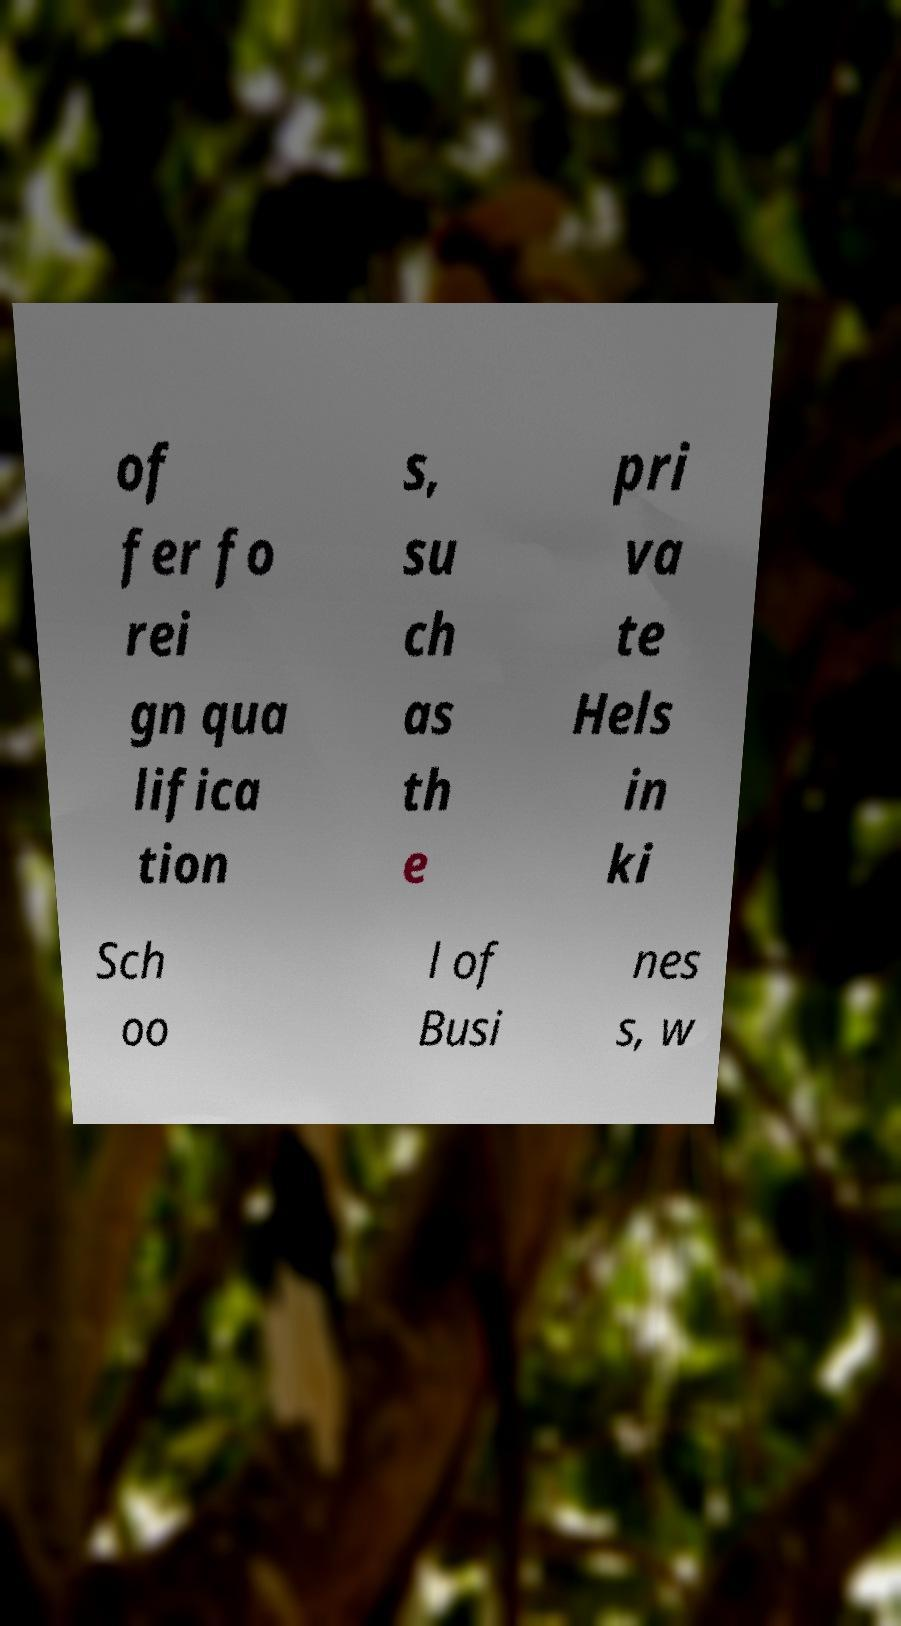What messages or text are displayed in this image? I need them in a readable, typed format. of fer fo rei gn qua lifica tion s, su ch as th e pri va te Hels in ki Sch oo l of Busi nes s, w 